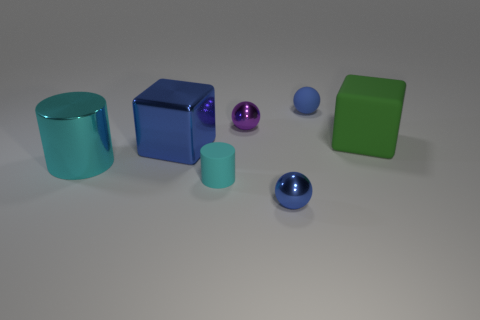Does the metallic thing in front of the cyan matte cylinder have the same color as the metallic sphere that is behind the large blue metallic cube?
Give a very brief answer. No. How many metallic things are red blocks or purple spheres?
Provide a succinct answer. 1. There is a small matte thing that is right of the tiny rubber thing that is in front of the large rubber thing; how many large matte objects are in front of it?
Your response must be concise. 1. What is the size of the block that is made of the same material as the purple ball?
Keep it short and to the point. Large. How many big cylinders are the same color as the tiny cylinder?
Ensure brevity in your answer.  1. Do the blue metallic object that is behind the rubber cylinder and the large cyan cylinder have the same size?
Your answer should be very brief. Yes. What color is the rubber object that is both in front of the blue rubber ball and right of the small matte cylinder?
Your answer should be compact. Green. What number of things are shiny spheres or cyan things that are on the right side of the blue cube?
Provide a short and direct response. 3. There is a tiny blue sphere that is in front of the blue shiny thing left of the small metallic object that is behind the big green cube; what is its material?
Give a very brief answer. Metal. Is there anything else that has the same material as the big blue object?
Provide a short and direct response. Yes. 